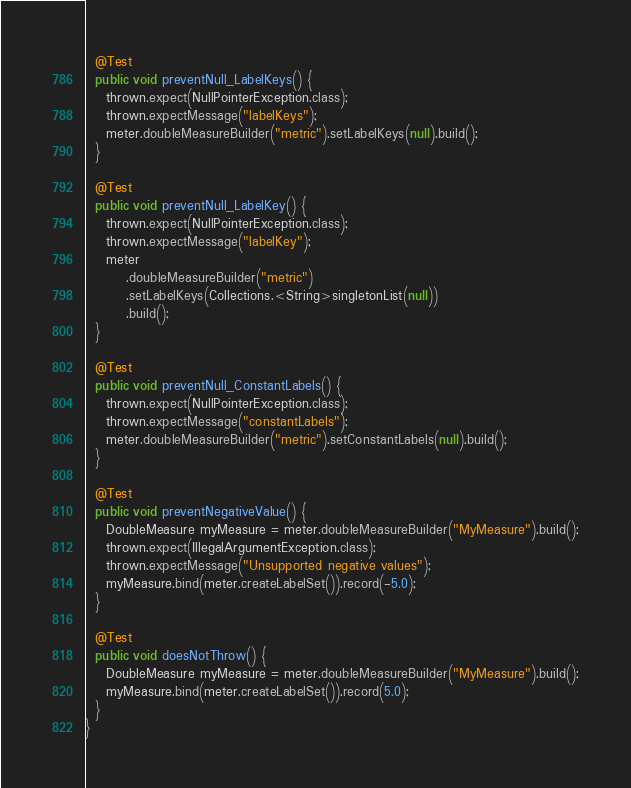Convert code to text. <code><loc_0><loc_0><loc_500><loc_500><_Java_>
  @Test
  public void preventNull_LabelKeys() {
    thrown.expect(NullPointerException.class);
    thrown.expectMessage("labelKeys");
    meter.doubleMeasureBuilder("metric").setLabelKeys(null).build();
  }

  @Test
  public void preventNull_LabelKey() {
    thrown.expect(NullPointerException.class);
    thrown.expectMessage("labelKey");
    meter
        .doubleMeasureBuilder("metric")
        .setLabelKeys(Collections.<String>singletonList(null))
        .build();
  }

  @Test
  public void preventNull_ConstantLabels() {
    thrown.expect(NullPointerException.class);
    thrown.expectMessage("constantLabels");
    meter.doubleMeasureBuilder("metric").setConstantLabels(null).build();
  }

  @Test
  public void preventNegativeValue() {
    DoubleMeasure myMeasure = meter.doubleMeasureBuilder("MyMeasure").build();
    thrown.expect(IllegalArgumentException.class);
    thrown.expectMessage("Unsupported negative values");
    myMeasure.bind(meter.createLabelSet()).record(-5.0);
  }

  @Test
  public void doesNotThrow() {
    DoubleMeasure myMeasure = meter.doubleMeasureBuilder("MyMeasure").build();
    myMeasure.bind(meter.createLabelSet()).record(5.0);
  }
}
</code> 